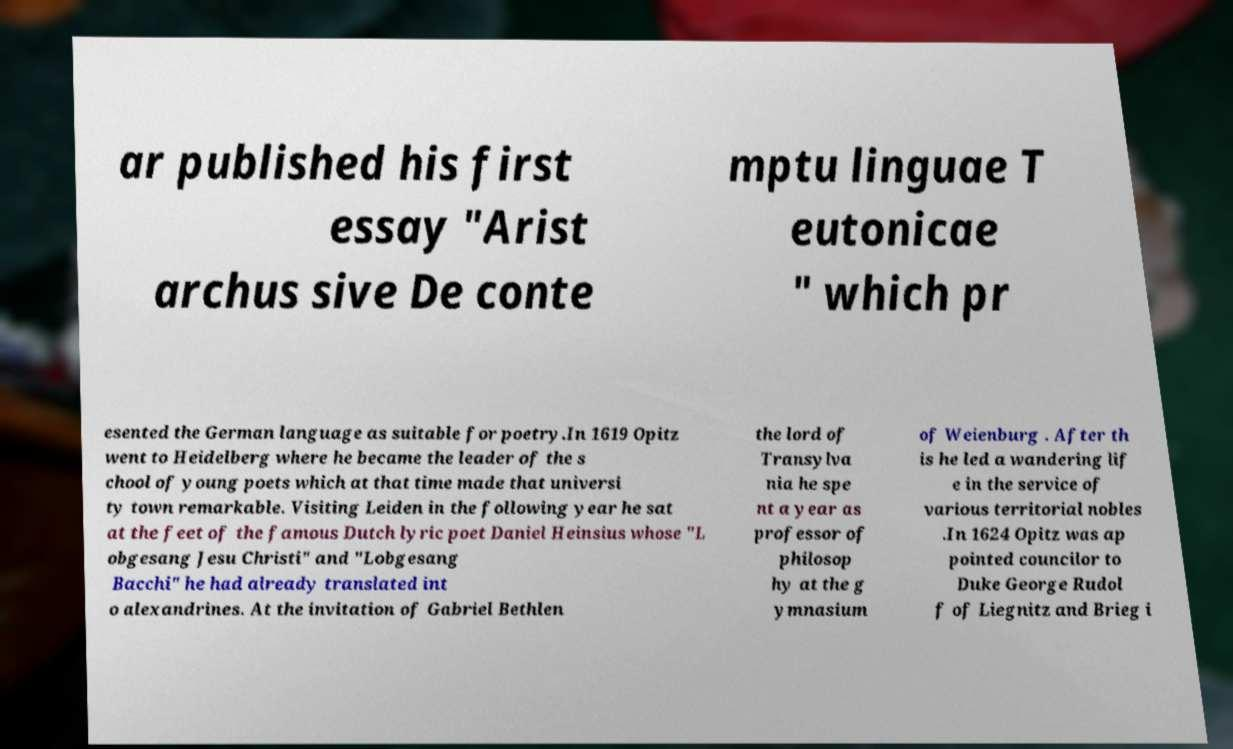Could you assist in decoding the text presented in this image and type it out clearly? ar published his first essay "Arist archus sive De conte mptu linguae T eutonicae " which pr esented the German language as suitable for poetry.In 1619 Opitz went to Heidelberg where he became the leader of the s chool of young poets which at that time made that universi ty town remarkable. Visiting Leiden in the following year he sat at the feet of the famous Dutch lyric poet Daniel Heinsius whose "L obgesang Jesu Christi" and "Lobgesang Bacchi" he had already translated int o alexandrines. At the invitation of Gabriel Bethlen the lord of Transylva nia he spe nt a year as professor of philosop hy at the g ymnasium of Weienburg . After th is he led a wandering lif e in the service of various territorial nobles .In 1624 Opitz was ap pointed councilor to Duke George Rudol f of Liegnitz and Brieg i 